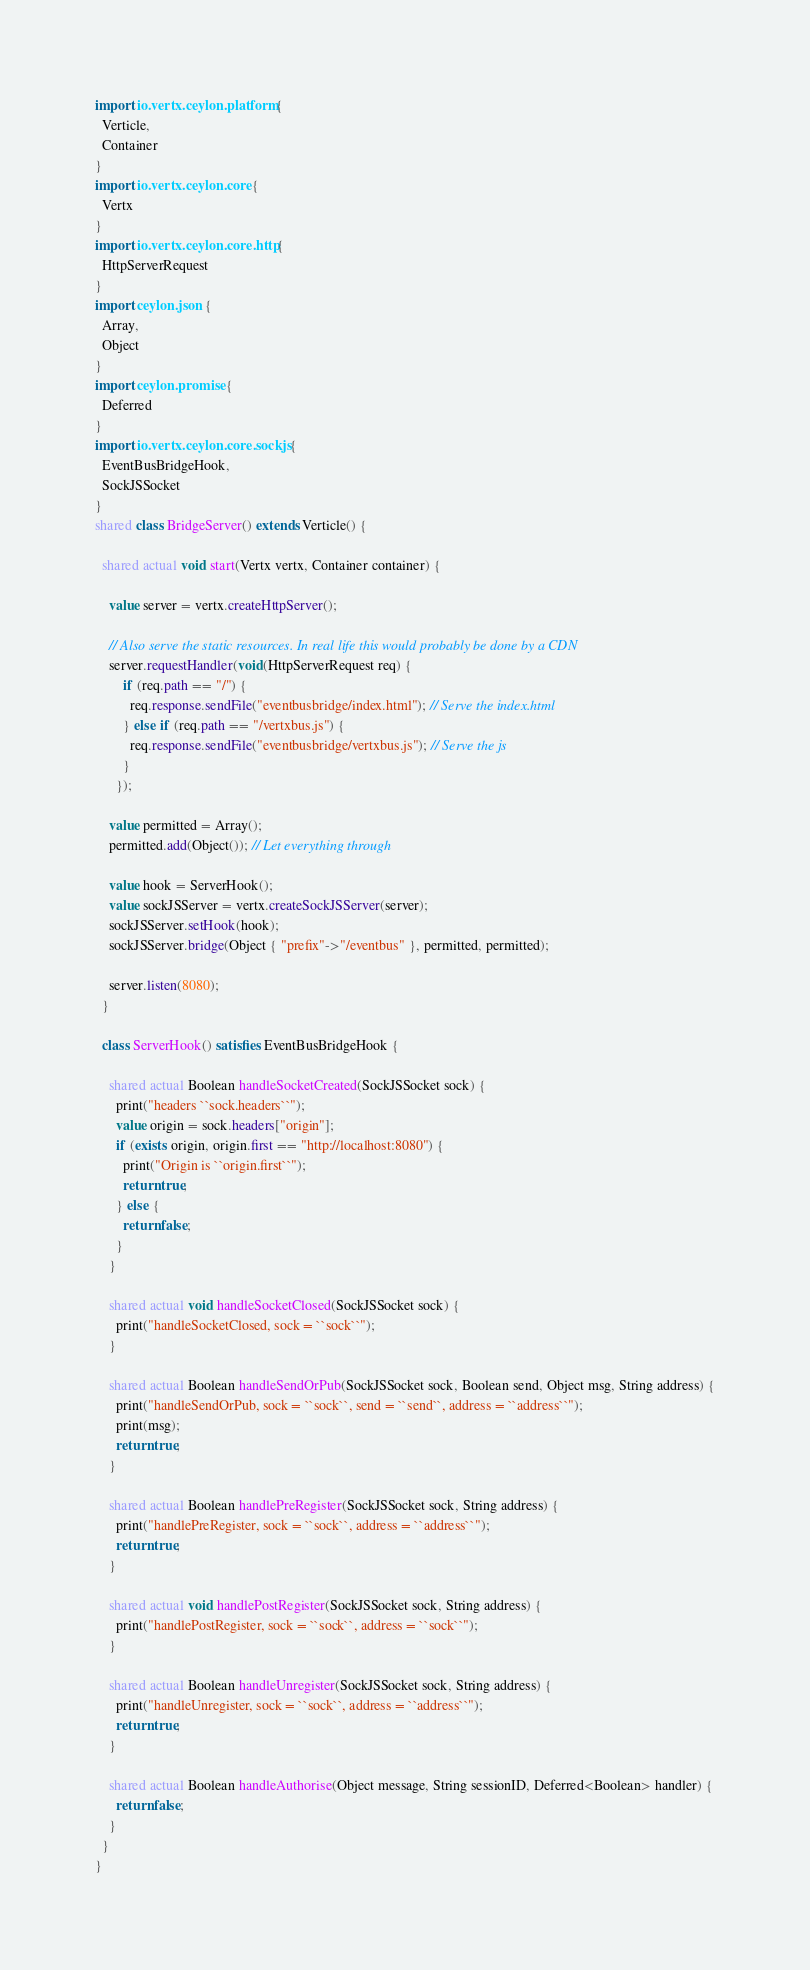Convert code to text. <code><loc_0><loc_0><loc_500><loc_500><_Ceylon_>import io.vertx.ceylon.platform {
  Verticle,
  Container
}
import io.vertx.ceylon.core {
  Vertx
}
import io.vertx.ceylon.core.http {
  HttpServerRequest
}
import ceylon.json {
  Array,
  Object
}
import ceylon.promise {
  Deferred
}
import io.vertx.ceylon.core.sockjs {
  EventBusBridgeHook,
  SockJSSocket
}
shared class BridgeServer() extends Verticle() {
  
  shared actual void start(Vertx vertx, Container container) {
    
    value server = vertx.createHttpServer();
    
    // Also serve the static resources. In real life this would probably be done by a CDN
    server.requestHandler(void(HttpServerRequest req) {
        if (req.path == "/") {
          req.response.sendFile("eventbusbridge/index.html"); // Serve the index.html
        } else if (req.path == "/vertxbus.js") {
          req.response.sendFile("eventbusbridge/vertxbus.js"); // Serve the js
        }
      });
    
    value permitted = Array();
    permitted.add(Object()); // Let everything through
    
    value hook = ServerHook();
    value sockJSServer = vertx.createSockJSServer(server);
    sockJSServer.setHook(hook);
    sockJSServer.bridge(Object { "prefix"->"/eventbus" }, permitted, permitted);
    
    server.listen(8080);
  }
  
  class ServerHook() satisfies EventBusBridgeHook {
    
    shared actual Boolean handleSocketCreated(SockJSSocket sock) {
      print("headers ``sock.headers``");
      value origin = sock.headers["origin"];
      if (exists origin, origin.first == "http://localhost:8080") {
        print("Origin is ``origin.first``");
        return true;
      } else {
        return false;
      }
    }
    
    shared actual void handleSocketClosed(SockJSSocket sock) {
      print("handleSocketClosed, sock = ``sock``");
    }
    
    shared actual Boolean handleSendOrPub(SockJSSocket sock, Boolean send, Object msg, String address) {
      print("handleSendOrPub, sock = ``sock``, send = ``send``, address = ``address``");
      print(msg);
      return true;
    }
    
    shared actual Boolean handlePreRegister(SockJSSocket sock, String address) {
      print("handlePreRegister, sock = ``sock``, address = ``address``");
      return true;
    }
    
    shared actual void handlePostRegister(SockJSSocket sock, String address) {
      print("handlePostRegister, sock = ``sock``, address = ``sock``");
    }
    
    shared actual Boolean handleUnregister(SockJSSocket sock, String address) {
      print("handleUnregister, sock = ``sock``, address = ``address``");
      return true;
    }
    
    shared actual Boolean handleAuthorise(Object message, String sessionID, Deferred<Boolean> handler) {
      return false;
    }
  }
}
</code> 